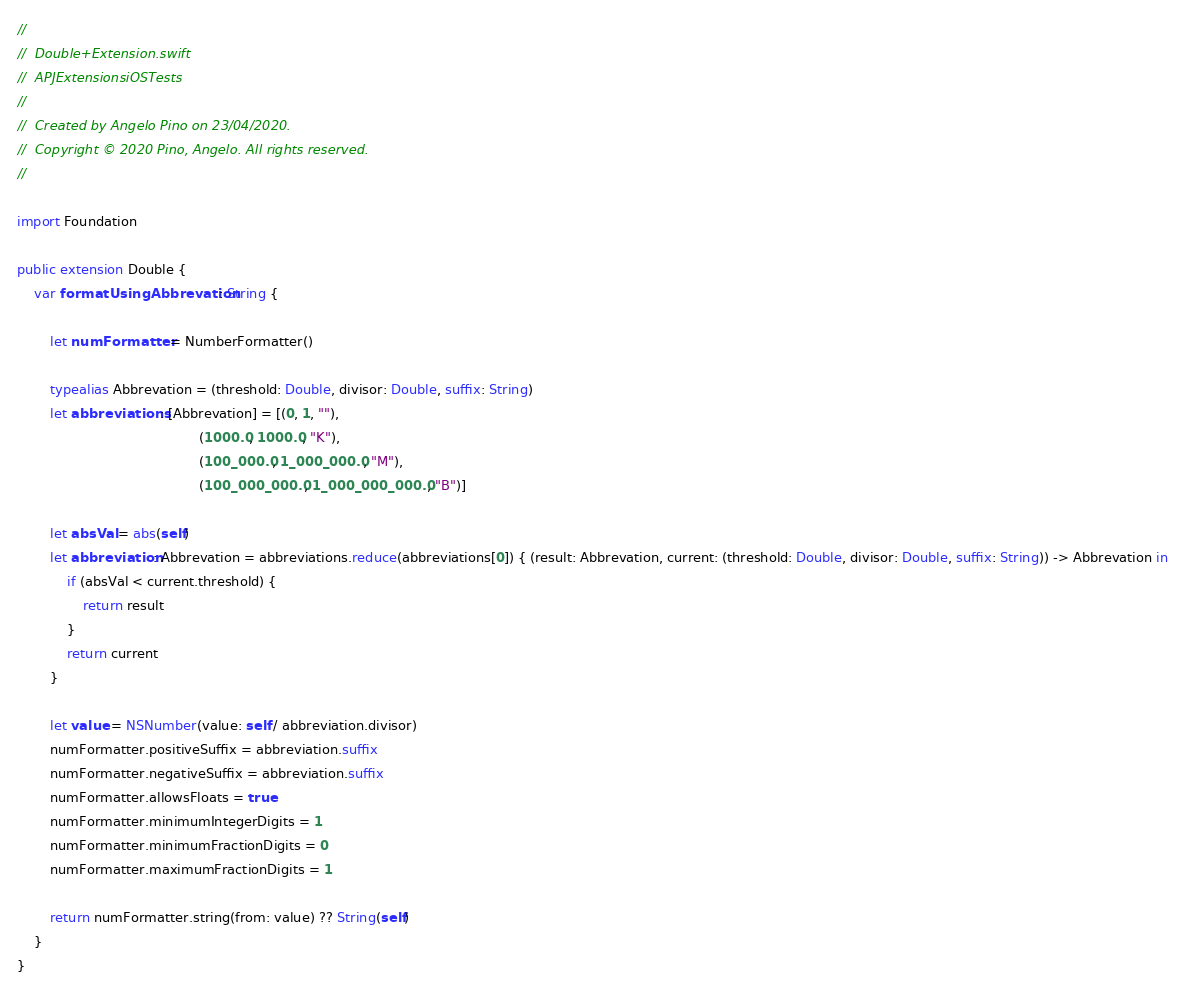<code> <loc_0><loc_0><loc_500><loc_500><_Swift_>//
//  Double+Extension.swift
//  APJExtensionsiOSTests
//
//  Created by Angelo Pino on 23/04/2020.
//  Copyright © 2020 Pino, Angelo. All rights reserved.
//

import Foundation

public extension Double {
    var formatUsingAbbrevation: String {
        
        let numFormatter = NumberFormatter()
        
        typealias Abbrevation = (threshold: Double, divisor: Double, suffix: String)
        let abbreviations: [Abbrevation] = [(0, 1, ""),
                                            (1000.0, 1000.0, "K"),
                                            (100_000.0, 1_000_000.0, "M"),
                                            (100_000_000.0, 1_000_000_000.0, "B")]
        
        let absVal = abs(self)
        let abbreviation: Abbrevation = abbreviations.reduce(abbreviations[0]) { (result: Abbrevation, current: (threshold: Double, divisor: Double, suffix: String)) -> Abbrevation in
            if (absVal < current.threshold) {
                return result
            }
            return current
        }
        
        let value = NSNumber(value: self / abbreviation.divisor)
        numFormatter.positiveSuffix = abbreviation.suffix
        numFormatter.negativeSuffix = abbreviation.suffix
        numFormatter.allowsFloats = true
        numFormatter.minimumIntegerDigits = 1
        numFormatter.minimumFractionDigits = 0
        numFormatter.maximumFractionDigits = 1
        
        return numFormatter.string(from: value) ?? String(self)
    }
}
</code> 